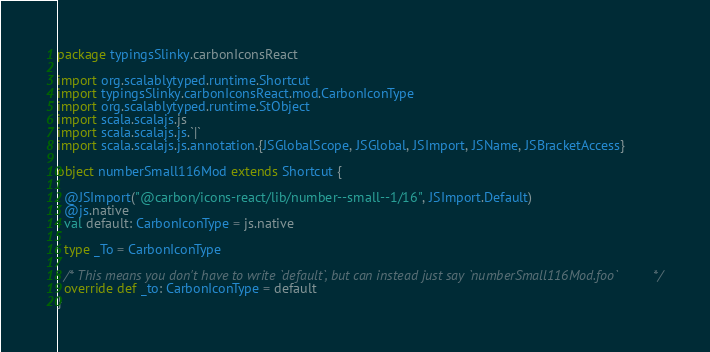Convert code to text. <code><loc_0><loc_0><loc_500><loc_500><_Scala_>package typingsSlinky.carbonIconsReact

import org.scalablytyped.runtime.Shortcut
import typingsSlinky.carbonIconsReact.mod.CarbonIconType
import org.scalablytyped.runtime.StObject
import scala.scalajs.js
import scala.scalajs.js.`|`
import scala.scalajs.js.annotation.{JSGlobalScope, JSGlobal, JSImport, JSName, JSBracketAccess}

object numberSmall116Mod extends Shortcut {
  
  @JSImport("@carbon/icons-react/lib/number--small--1/16", JSImport.Default)
  @js.native
  val default: CarbonIconType = js.native
  
  type _To = CarbonIconType
  
  /* This means you don't have to write `default`, but can instead just say `numberSmall116Mod.foo` */
  override def _to: CarbonIconType = default
}
</code> 